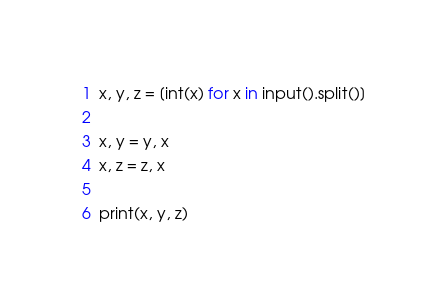<code> <loc_0><loc_0><loc_500><loc_500><_Python_>x, y, z = [int(x) for x in input().split()]

x, y = y, x
x, z = z, x

print(x, y, z)</code> 